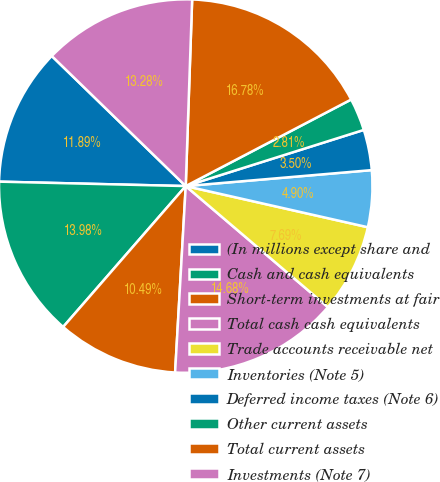Convert chart to OTSL. <chart><loc_0><loc_0><loc_500><loc_500><pie_chart><fcel>(In millions except share and<fcel>Cash and cash equivalents<fcel>Short-term investments at fair<fcel>Total cash cash equivalents<fcel>Trade accounts receivable net<fcel>Inventories (Note 5)<fcel>Deferred income taxes (Note 6)<fcel>Other current assets<fcel>Total current assets<fcel>Investments (Note 7)<nl><fcel>11.89%<fcel>13.98%<fcel>10.49%<fcel>14.68%<fcel>7.69%<fcel>4.9%<fcel>3.5%<fcel>2.81%<fcel>16.78%<fcel>13.28%<nl></chart> 